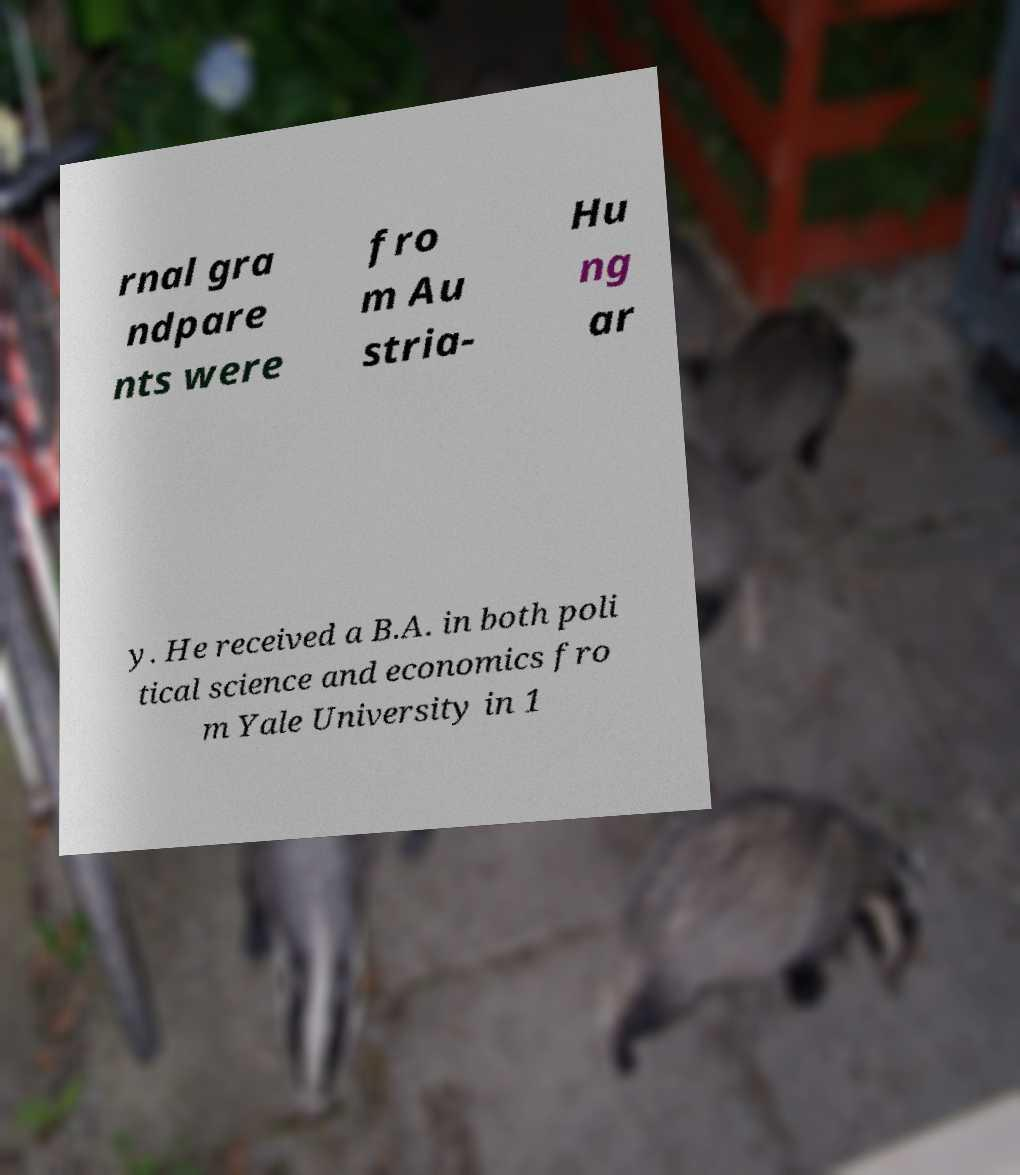Can you read and provide the text displayed in the image?This photo seems to have some interesting text. Can you extract and type it out for me? rnal gra ndpare nts were fro m Au stria- Hu ng ar y. He received a B.A. in both poli tical science and economics fro m Yale University in 1 